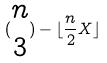<formula> <loc_0><loc_0><loc_500><loc_500>( \begin{matrix} n \\ 3 \end{matrix} ) - \lfloor \frac { n } { 2 } X \rfloor</formula> 